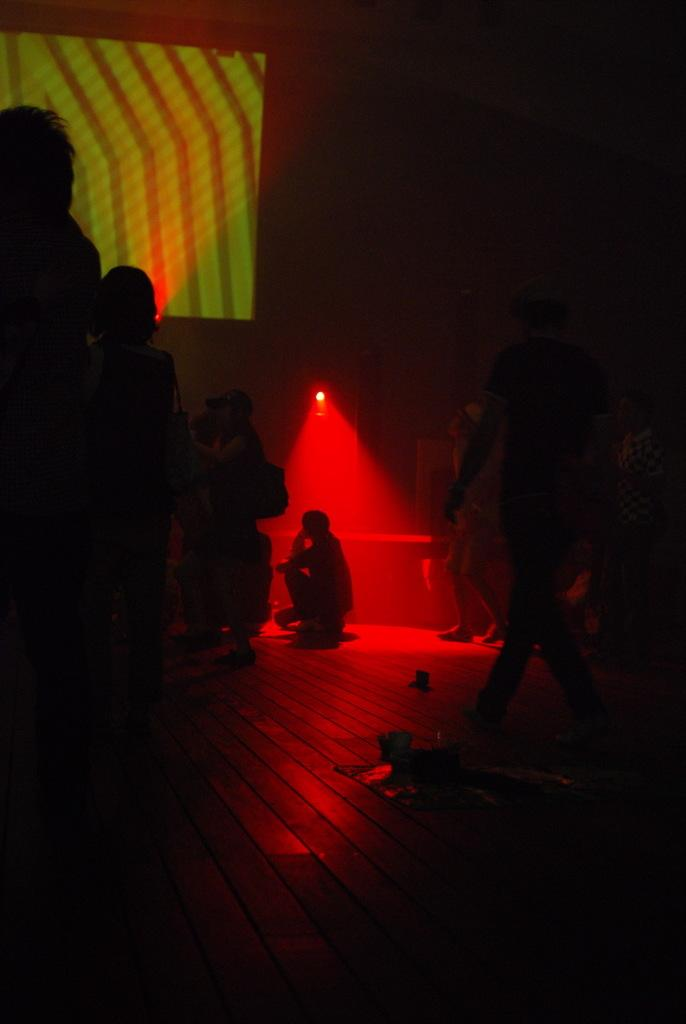How many people are visible in the image? There are many people in the image. Can you describe the person in the center of the image? There is a person in the center of the image. What is the purpose of the light in the image? The light is focused on the person in the center. What type of plate is being played by the band in the image? There is no band or plate present in the image. 